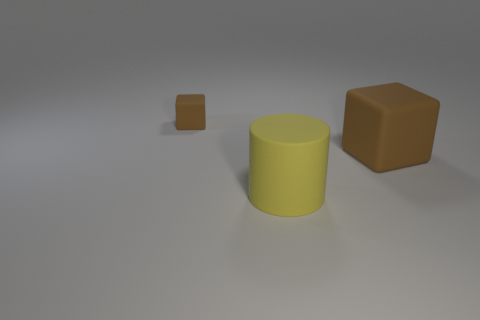What time of day or lighting conditions does the image suggest? The image suggests an indoor setting with artificial lighting, given the soft shadows cast by the objects. The light source appears to be overhead, as indicated by the direction of the shadows, and there's a gentle gradient in the lighting intensity across the surface, hinting at a controlled, perhaps studio-like environment. 